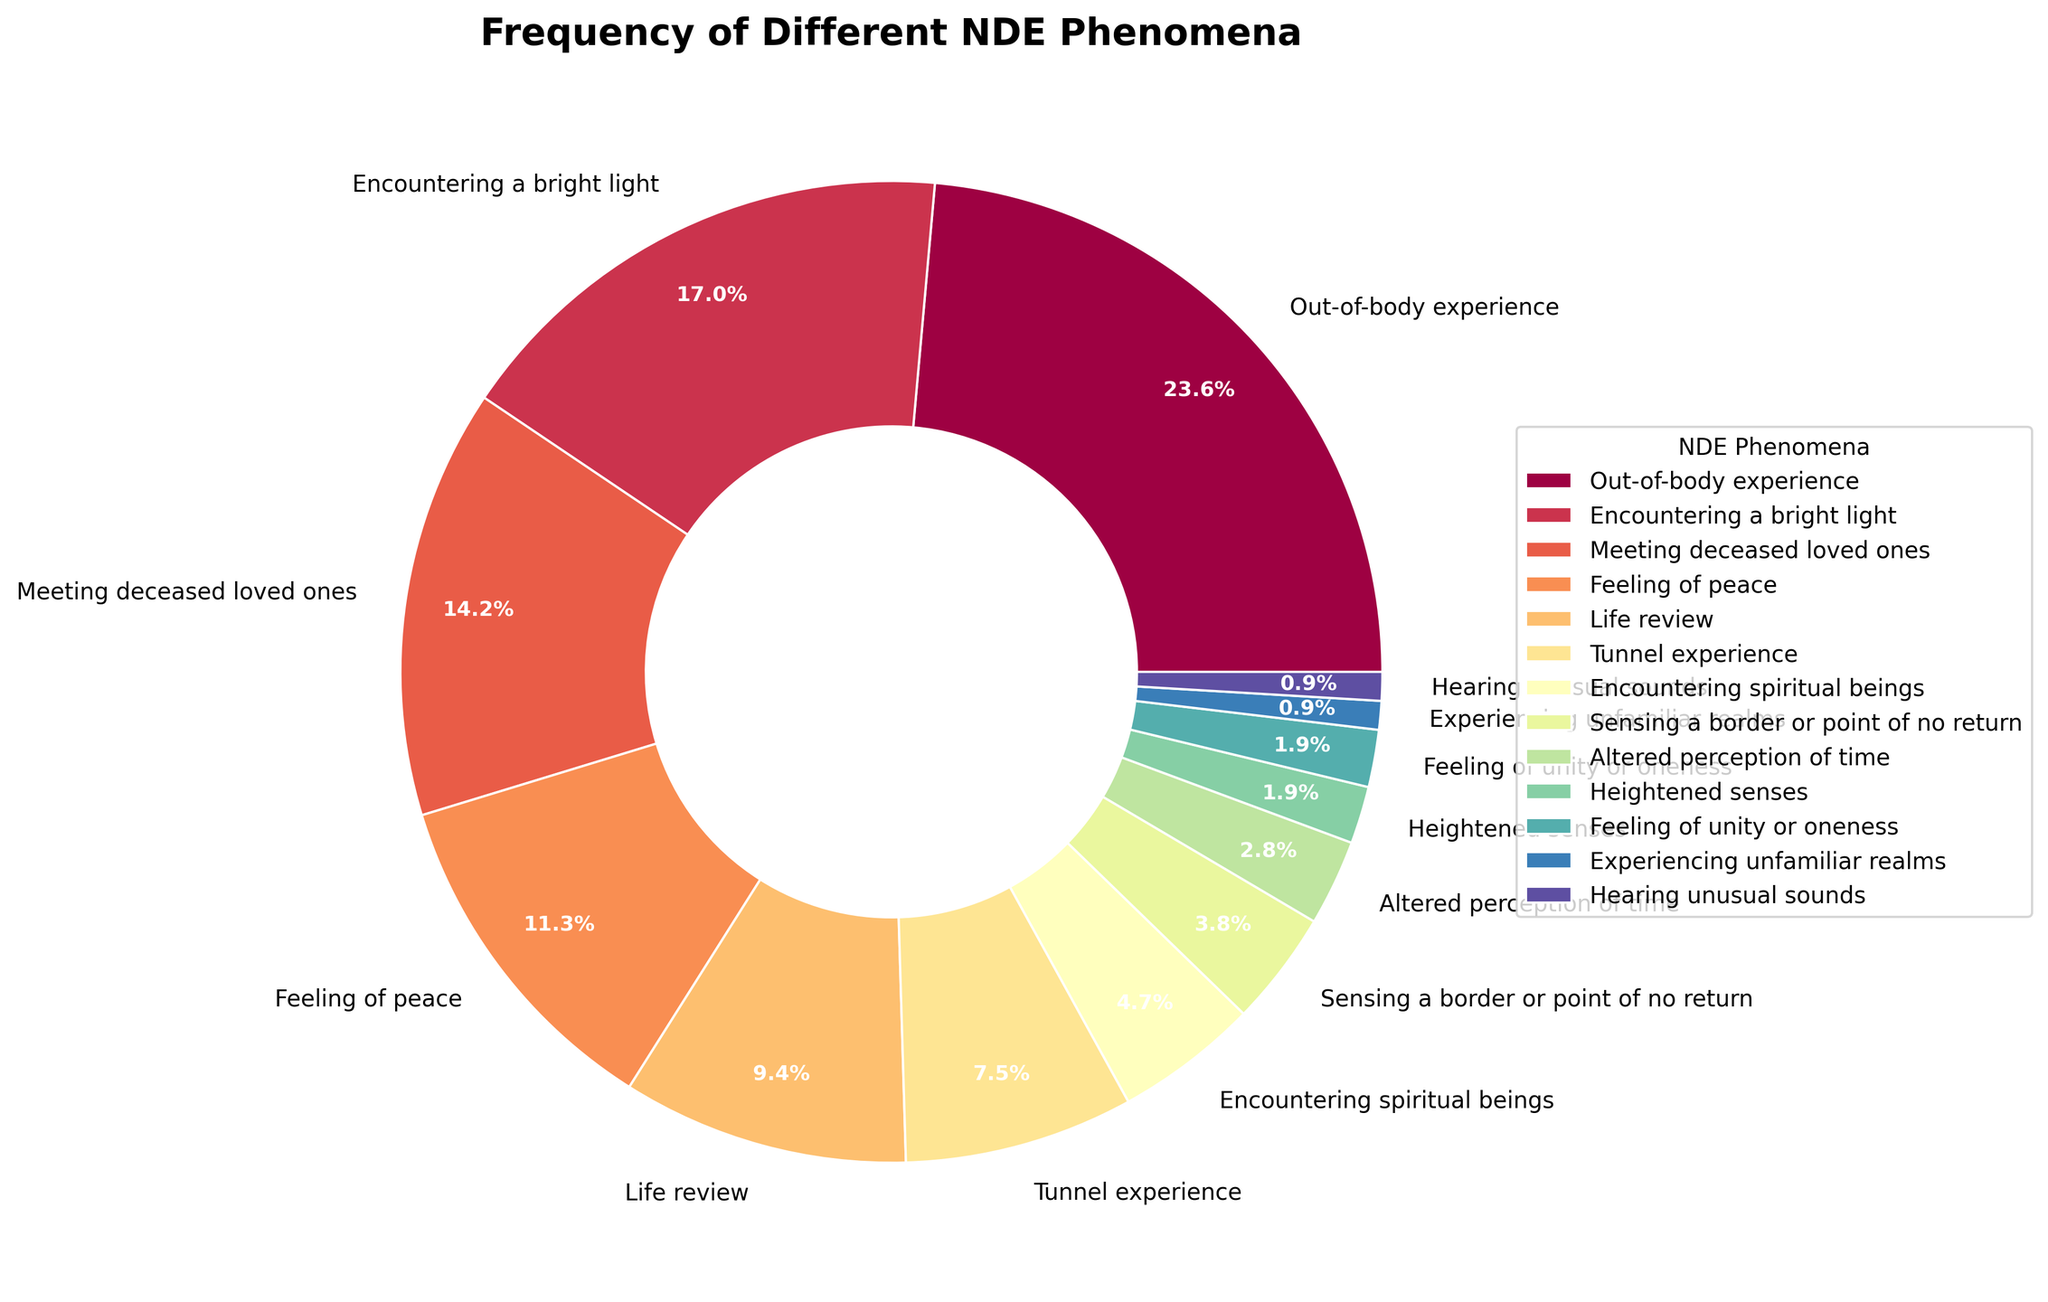what is the most frequently experienced NDE phenomenon? The figure shows the percentage distribution of different NDE phenomena. The largest wedge in the pie chart represents the most frequently experienced phenomenon, which is the out-of-body experience at 25%.
Answer: Out-of-body experience What's the combined percentage of encountering a bright light and meeting deceased loved ones? To find the combined percentage, locate the wedges for encountering a bright light and meeting deceased loved ones, which are 18% and 15% respectively. Add these two percentages together: 18 + 15 = 33%.
Answer: 33% Which phenomenon is less frequent: sensing a border or point of no return, or heightened senses? By comparing the percentages in the pie chart, sensing a border or point of no return has 4%, and heightened senses have 2%. Since 2% is less than 4%, heightened senses is the less frequent phenomenon.
Answer: heightened senses Are there more phenomena with a frequency higher than 10% or lower than 10%? Count the number of phenomena with frequencies above 10% (there are four: out-of-body experience-25%, encountering a bright light-18%, meeting deceased loved ones-15%, feeling of peace-12%) and below 10% (there are eight: life review-10%, tunnel experience-8%, encountering spiritual beings-5%, sensing a border or point of no return-4%, altered perception of time-3%, heightened senses-2%, feeling of unity or oneness-2%, experiencing unfamiliar realms-1%, hearing unusual sounds-1%). Since 8 is greater than 4, there are more phenomena with frequencies lower than 10%.
Answer: lower than 10% What's the difference in frequency between the tunnel experience and encountering spiritual beings? The pie chart shows the percentages for tunnel experience (8%) and encountering spiritual beings (5%). Subtract the smaller percentage from the larger one: 8 - 5 = 3%.
Answer: 3% Which phenomenon has a smaller frequency: feeling of unity or oneness, or altered perception of time? The pie chart shows that feeling of unity or oneness has a frequency of 2%, while altered perception of time has a frequency of 3%. Since 2% is less than 3%, feeling of unity or oneness has a smaller frequency.
Answer: feeling of unity or oneness What is the total percentage for phenomena related to sensory experiences (heightened senses and hearing unusual sounds)? Add the percentages for heightened senses (2%) and hearing unusual sounds (1%): 2 + 1 = 3%.
Answer: 3% How much more frequent is the life review phenomenon compared to the tunnel experience? The pie chart shows life review at 10% and tunnel experience at 8%. Subtract the tunnel experience percentage from the life review percentage: 10 - 8 = 2%.
Answer: 2% What is the ratio of the frequency of encountering a bright light to the frequency of feeling of peace? The pie chart shows encountering a bright light at 18% and feeling of peace at 12%. To find the ratio, divide 18 by 12: 18 ÷ 12 = 1.5. The ratio is 1.5:1.
Answer: 1.5:1 